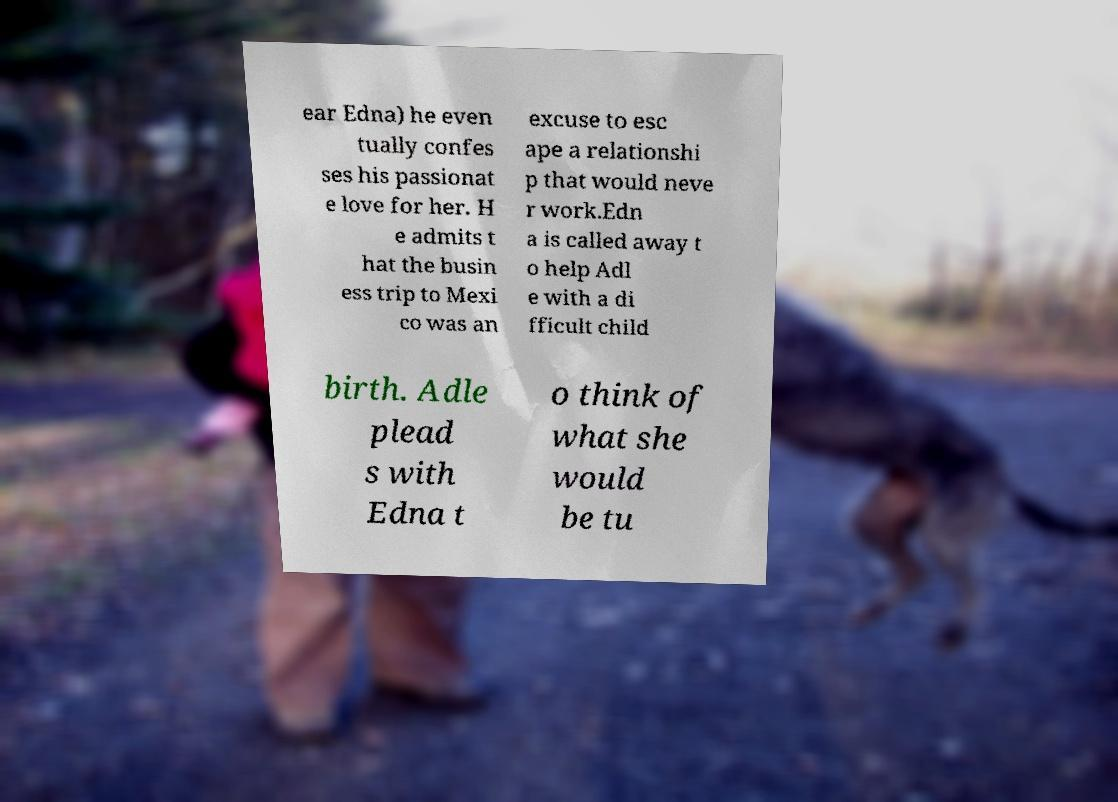Could you assist in decoding the text presented in this image and type it out clearly? ear Edna) he even tually confes ses his passionat e love for her. H e admits t hat the busin ess trip to Mexi co was an excuse to esc ape a relationshi p that would neve r work.Edn a is called away t o help Adl e with a di fficult child birth. Adle plead s with Edna t o think of what she would be tu 